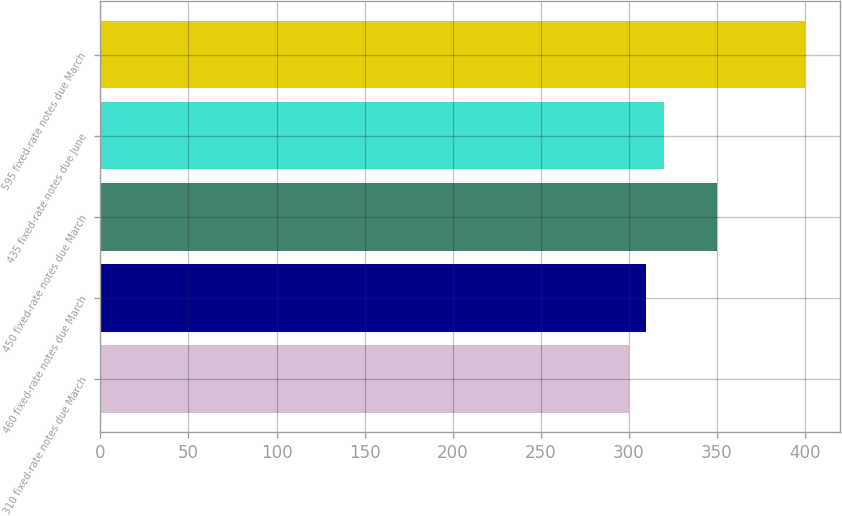<chart> <loc_0><loc_0><loc_500><loc_500><bar_chart><fcel>310 fixed-rate notes due March<fcel>460 fixed-rate notes due March<fcel>450 fixed-rate notes due March<fcel>435 fixed-rate notes due June<fcel>595 fixed-rate notes due March<nl><fcel>300<fcel>310<fcel>350<fcel>320<fcel>400<nl></chart> 